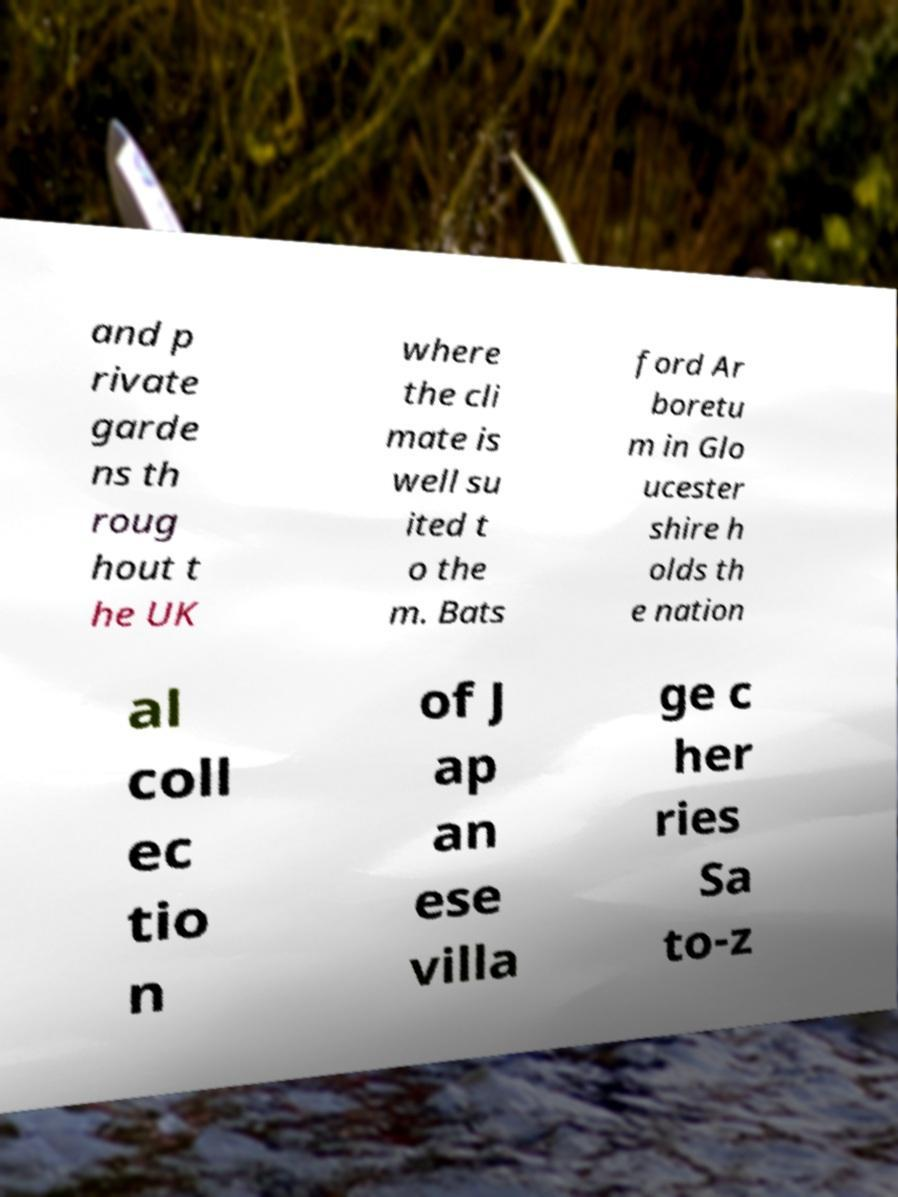Please identify and transcribe the text found in this image. and p rivate garde ns th roug hout t he UK where the cli mate is well su ited t o the m. Bats ford Ar boretu m in Glo ucester shire h olds th e nation al coll ec tio n of J ap an ese villa ge c her ries Sa to-z 